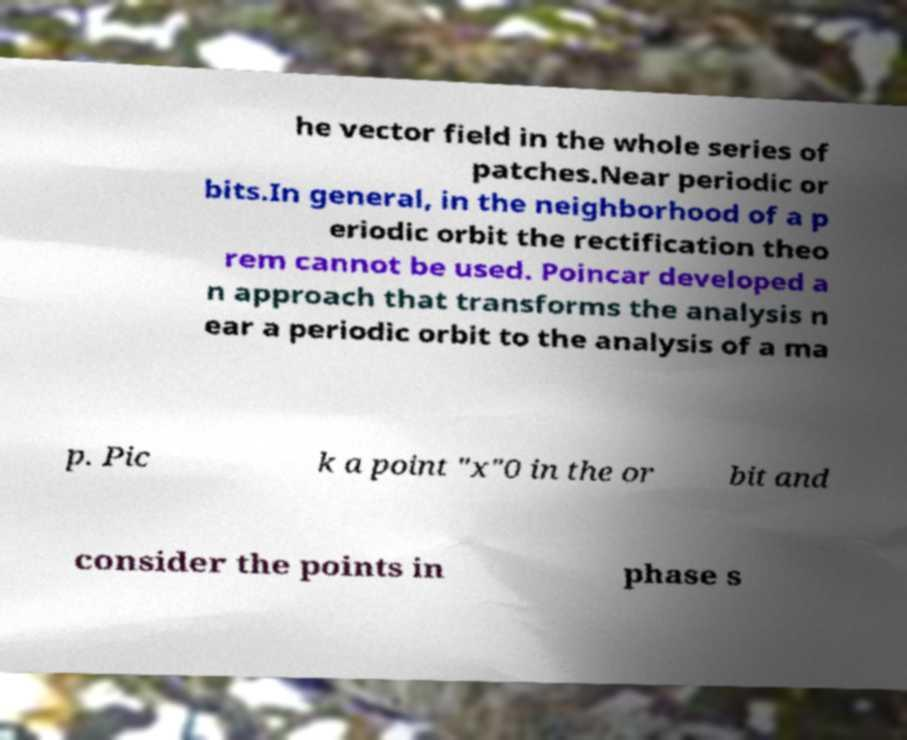Please identify and transcribe the text found in this image. he vector field in the whole series of patches.Near periodic or bits.In general, in the neighborhood of a p eriodic orbit the rectification theo rem cannot be used. Poincar developed a n approach that transforms the analysis n ear a periodic orbit to the analysis of a ma p. Pic k a point "x"0 in the or bit and consider the points in phase s 